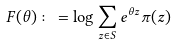<formula> <loc_0><loc_0><loc_500><loc_500>F ( \theta ) \colon = \log \sum _ { z \in S } e ^ { \theta z } \pi ( z )</formula> 